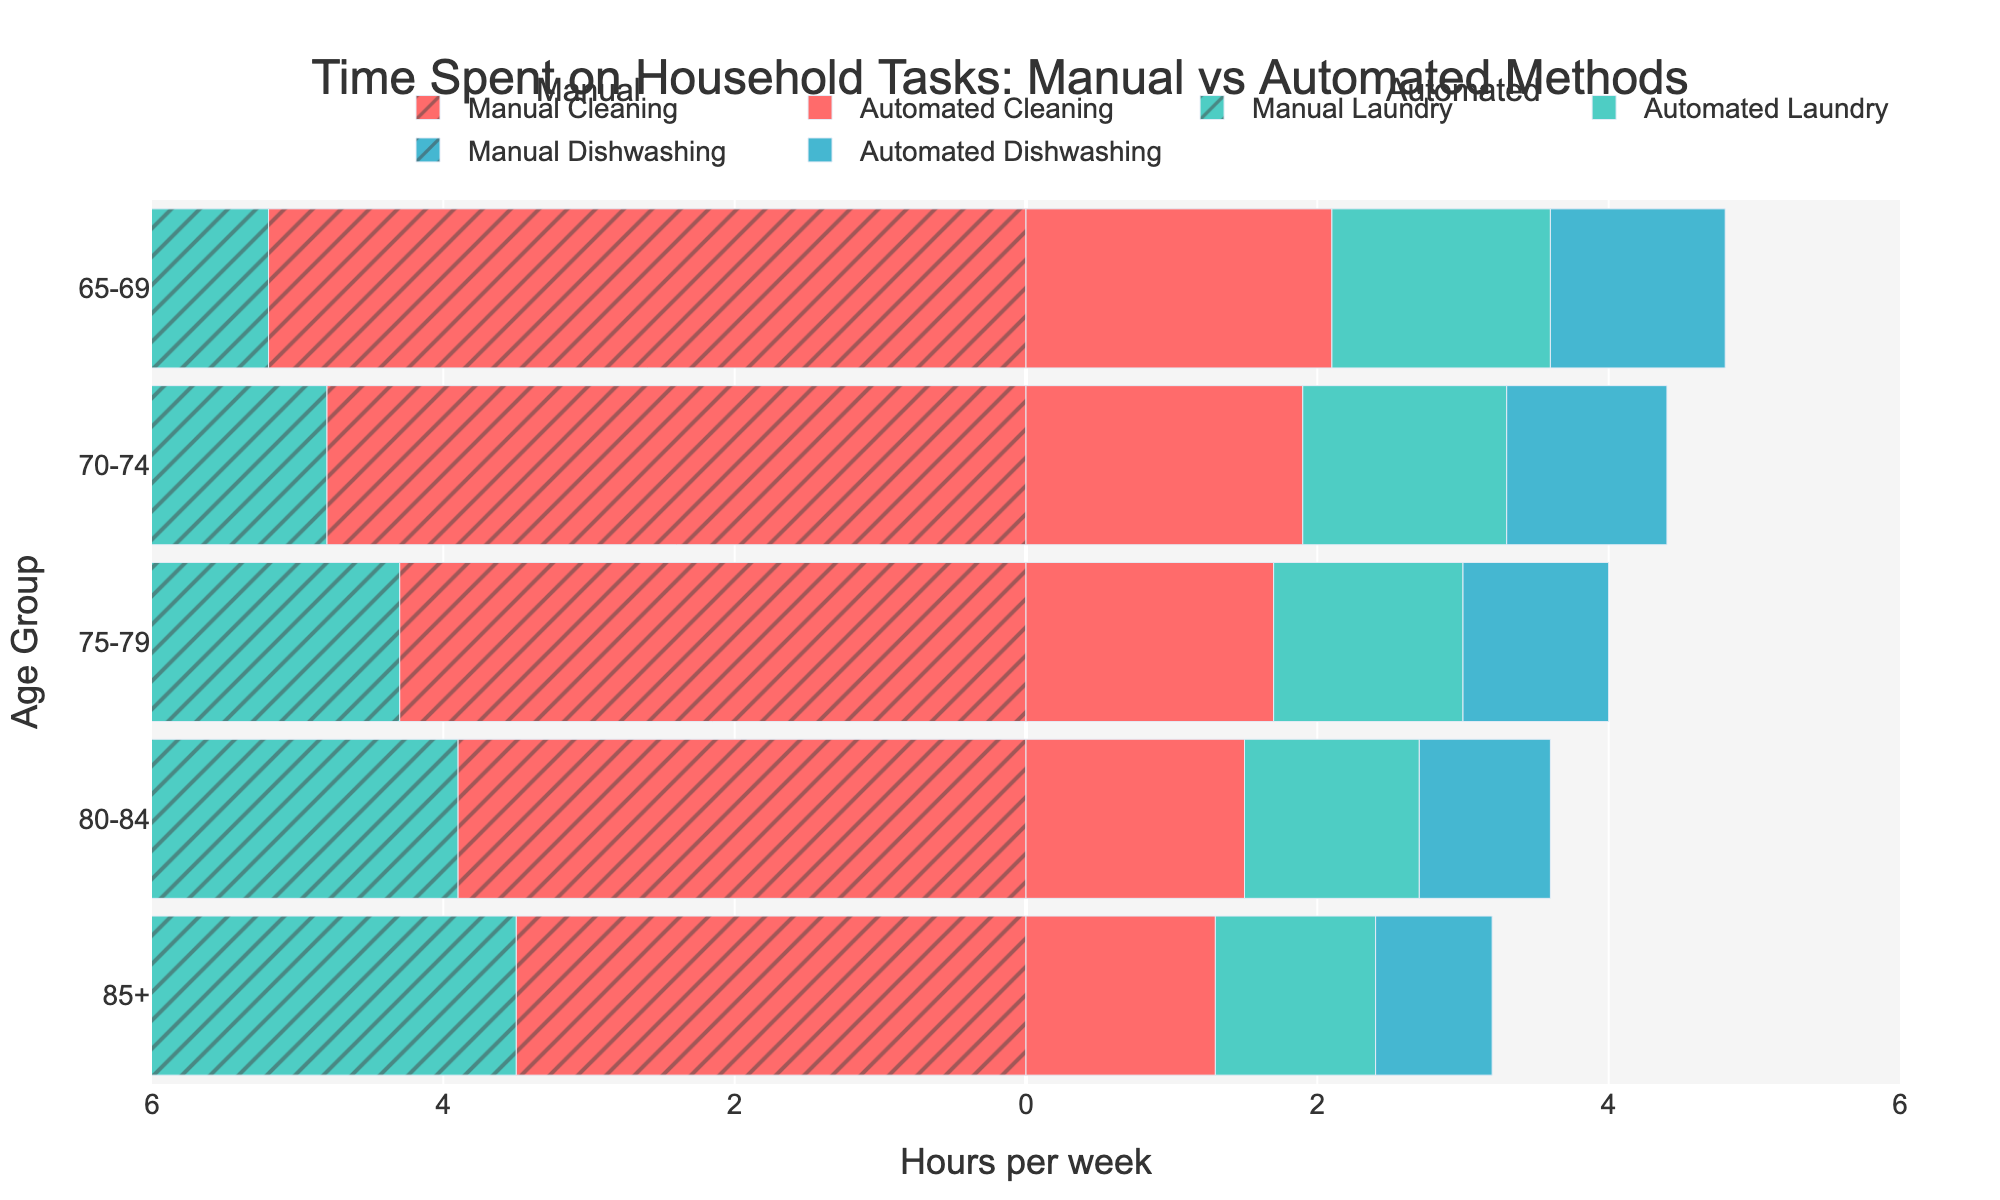What is the title of the figure? The title is at the top of the figure and reads 'Time Spent on Household Tasks: Manual vs Automated Methods'.
Answer: Time Spent on Household Tasks: Manual vs Automated Methods How many age groups are represented in the figure? By counting the number of different age ranges listed on the y-axis, we see there are 5 age groups represented.
Answer: 5 Which household task has the highest manual time for the age group 65-69? Locate the age group 65-69 on the y-axis, then compare the lengths of the manual bars for Cleaning, Laundry, and Dishwashing. The Manual Cleaning bar is the longest.
Answer: Cleaning What is the difference in hours between Manual and Automated Cleaning for the age group 70-74? For the age group 70-74, the Manual Cleaning bar is at -4.8 hours, and the Automated Cleaning bar is at 1.9 hours. The difference is 4.8 - 1.9 = 2.9 hours.
Answer: 2.9 hours Which age group shows the least difference between Manual and Automated Dishwashing time? Compare the differences between Manual and Automated Dishwashing bars for each age group. The 85+ age group has bars at 3.3 (Manual) and 0.8 (Automated), giving a difference of 3.3 - 0.8 = 2.5 hours, which is the least among all groups.
Answer: 85+ What is the average manual laundry time across all age groups? Sum the manual laundry times (3.8, 3.5, 3.2, 2.9, 2.6) and divide by the number of age groups (5). The sum is 16.0 hours, so the average is 16.0 / 5 = 3.2 hours.
Answer: 3.2 hours For the age group 80-84, which task saves the most time when automated compared to manual? For the age group 80-84, compare the time saved for each task: Cleaning (3.9 - 1.5 = 2.4 hours), Laundry (2.9 - 1.2 = 1.7 hours), and Dishwashing (3.6 - 0.9 = 2.7 hours). Dishwashing saves the most time at 2.7 hours.
Answer: Dishwashing Do older age groups (80-84 and 85+) spend less time on manual household tasks compared to younger age groups (65-69 and 70-74)? Compare the manual task times for each age group and observe that the older age groups (80-84 and 85+) have consistently smaller manual task times compared to younger age groups (65-69 and 70-74).
Answer: Yes What is the total automated time saved per week for the age group 75-79 across all tasks? First, calculate the time saved for each task in the 75-79 age group: Cleaning (4.3 - 1.7 = 2.6 hours), Laundry (3.2 - 1.3 = 1.9 hours), and Dishwashing (3.9 - 1.0 = 2.9 hours). Sum these values (2.6 + 1.9 + 2.9 = 7.4 hours).
Answer: 7.4 hours Which age group benefits the most from automating laundry chores? Compare the time saved for laundry chores by subtracting the automated times from the manual times for each age group. The 65-69 age group saves the most time on laundry (3.8 - 1.5 = 2.3 hours).
Answer: 65-69 